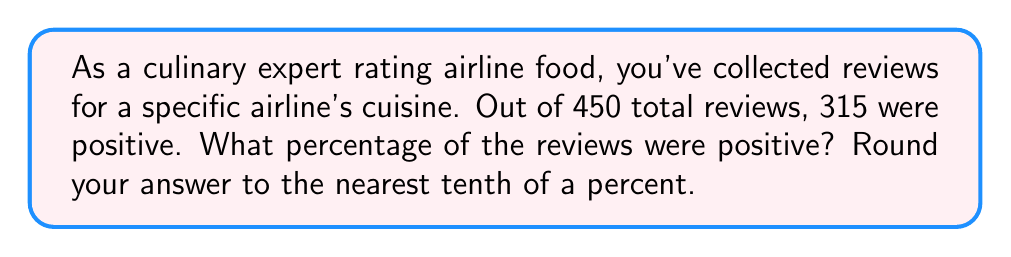Provide a solution to this math problem. To solve this problem, we need to follow these steps:

1. Identify the total number of reviews and the number of positive reviews:
   Total reviews: 450
   Positive reviews: 315

2. Calculate the percentage using the formula:
   $$ \text{Percentage} = \frac{\text{Number of positive reviews}}{\text{Total number of reviews}} \times 100\% $$

3. Plug in the values:
   $$ \text{Percentage} = \frac{315}{450} \times 100\% $$

4. Simplify the fraction:
   $$ \text{Percentage} = 0.7 \times 100\% $$

5. Multiply:
   $$ \text{Percentage} = 70\% $$

6. Round to the nearest tenth of a percent:
   The result is already in tenths, so no further rounding is necessary.

Therefore, 70.0% of the reviews were positive.
Answer: 70.0% 